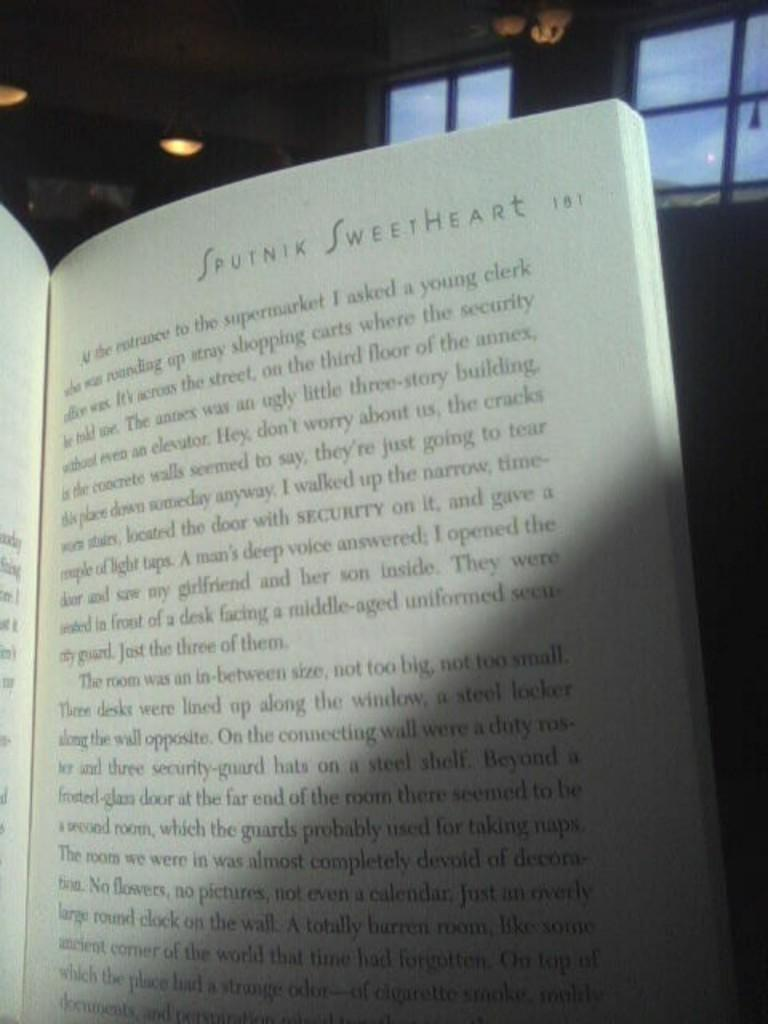<image>
Relay a brief, clear account of the picture shown. The page number of the book is 181. 